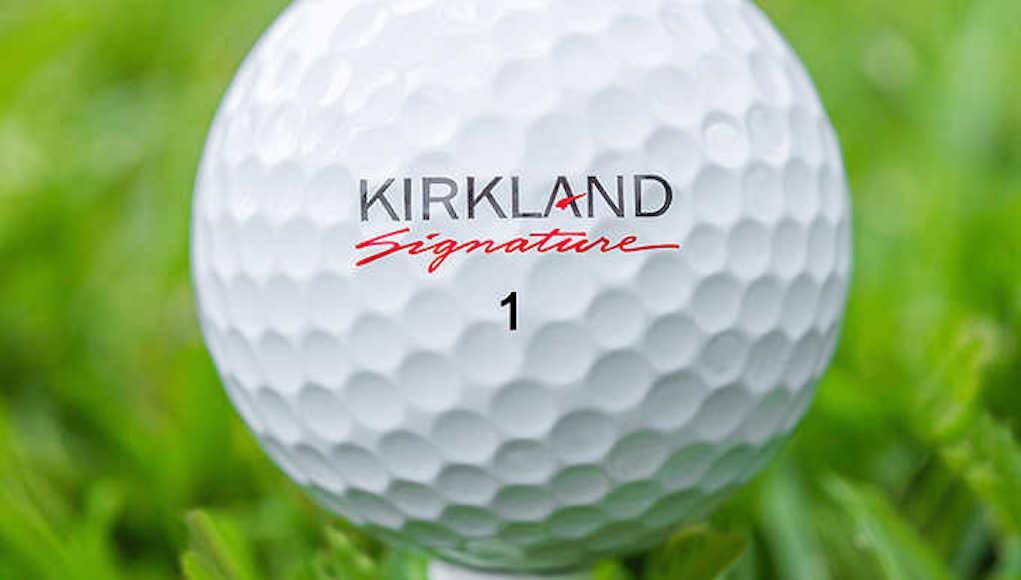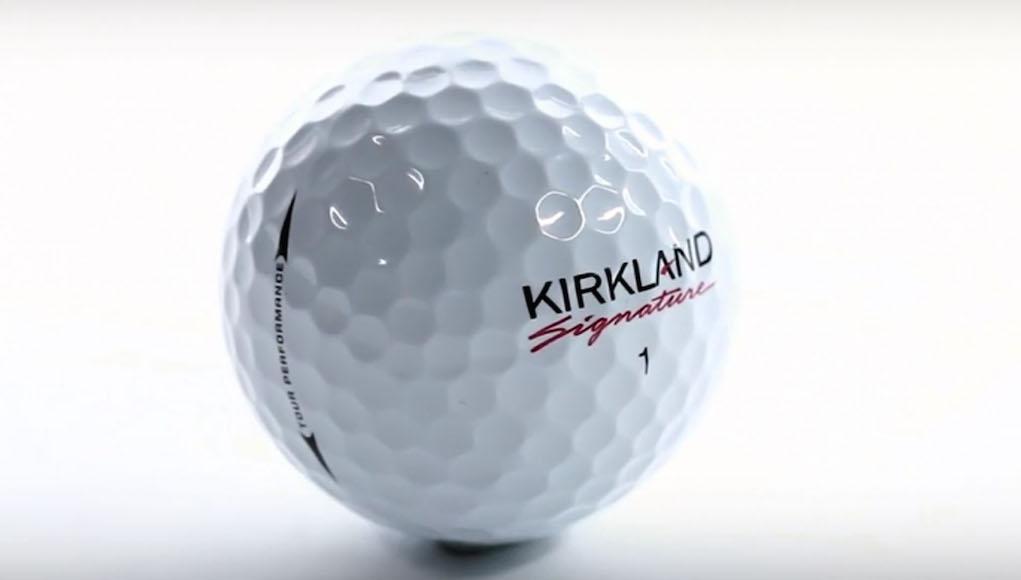The first image is the image on the left, the second image is the image on the right. Analyze the images presented: Is the assertion "Two golf balls are not in a box." valid? Answer yes or no. Yes. 